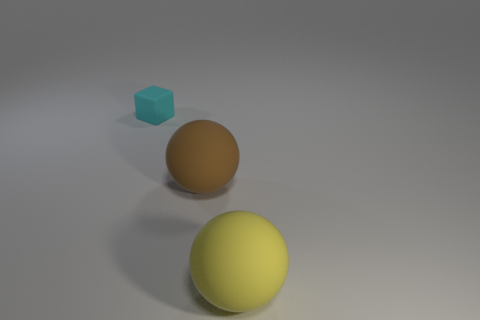Subtract all brown balls. Subtract all red cylinders. How many balls are left? 1 Add 1 big objects. How many objects exist? 4 Subtract all spheres. How many objects are left? 1 Subtract all yellow things. Subtract all yellow spheres. How many objects are left? 1 Add 1 small matte objects. How many small matte objects are left? 2 Add 1 yellow metal balls. How many yellow metal balls exist? 1 Subtract 0 red balls. How many objects are left? 3 